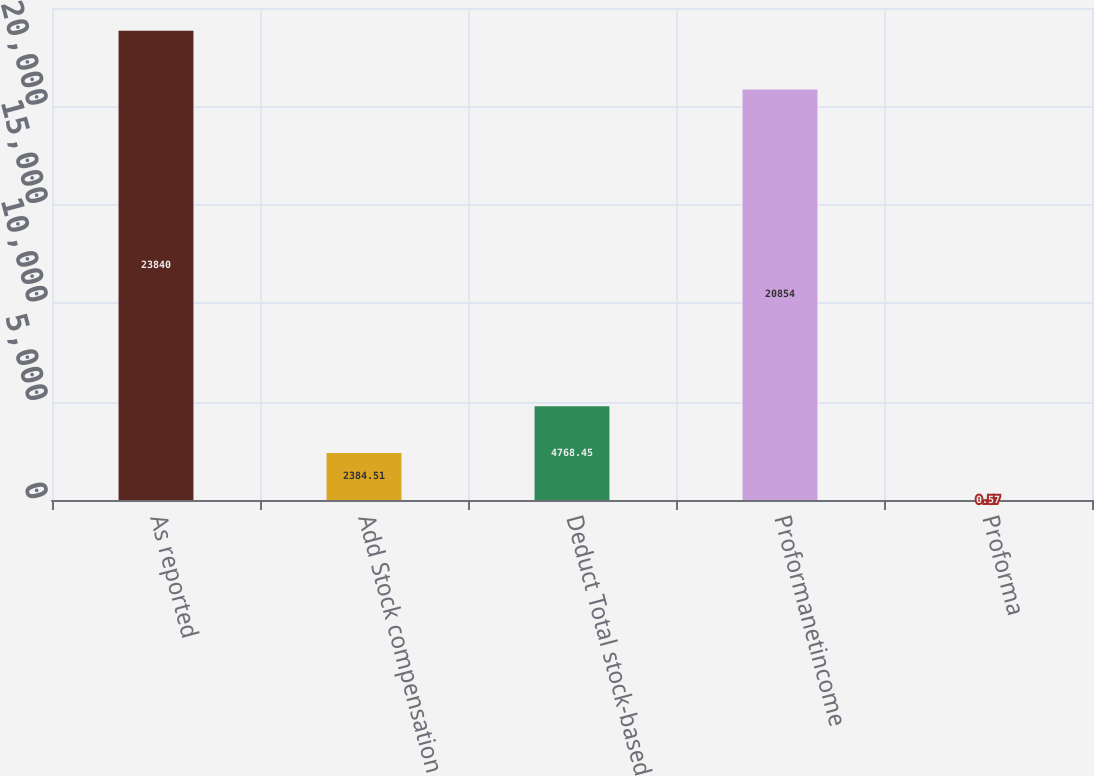Convert chart. <chart><loc_0><loc_0><loc_500><loc_500><bar_chart><fcel>As reported<fcel>Add Stock compensation<fcel>Deduct Total stock-based<fcel>Proformanetincome<fcel>Proforma<nl><fcel>23840<fcel>2384.51<fcel>4768.45<fcel>20854<fcel>0.57<nl></chart> 